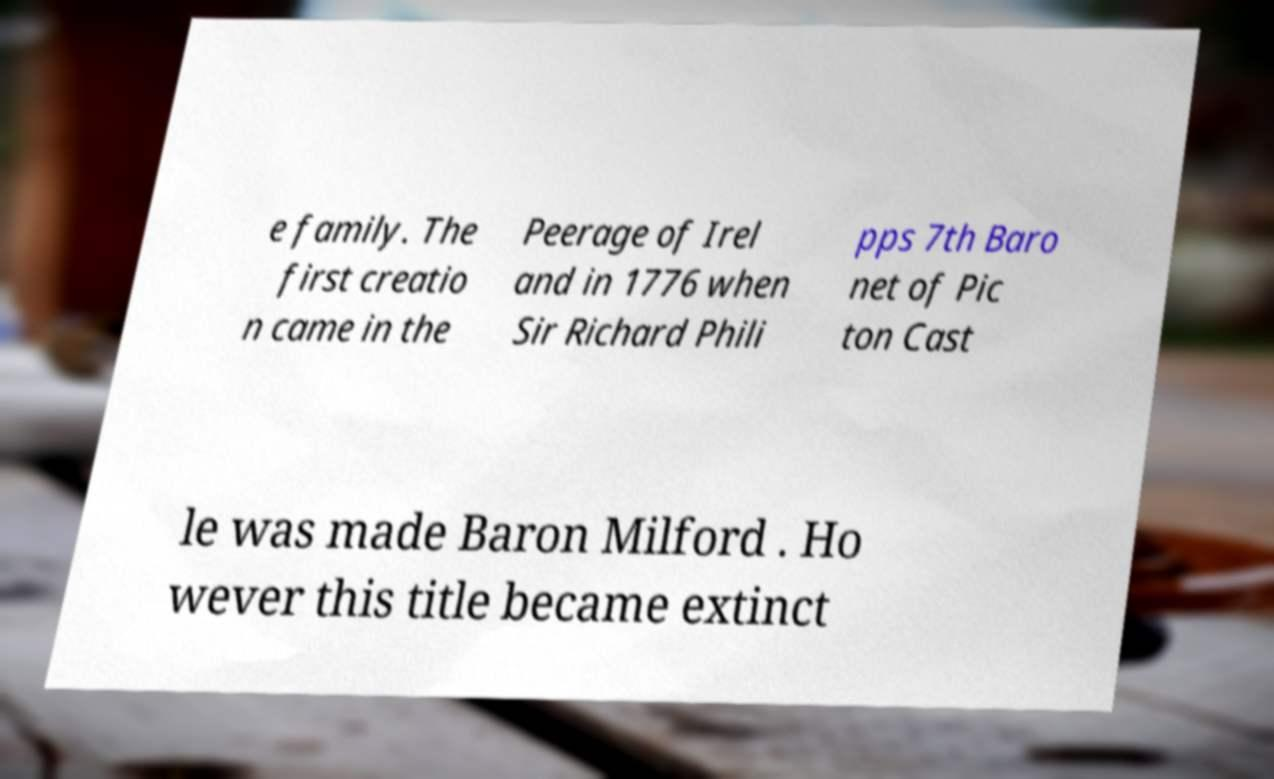Can you accurately transcribe the text from the provided image for me? e family. The first creatio n came in the Peerage of Irel and in 1776 when Sir Richard Phili pps 7th Baro net of Pic ton Cast le was made Baron Milford . Ho wever this title became extinct 